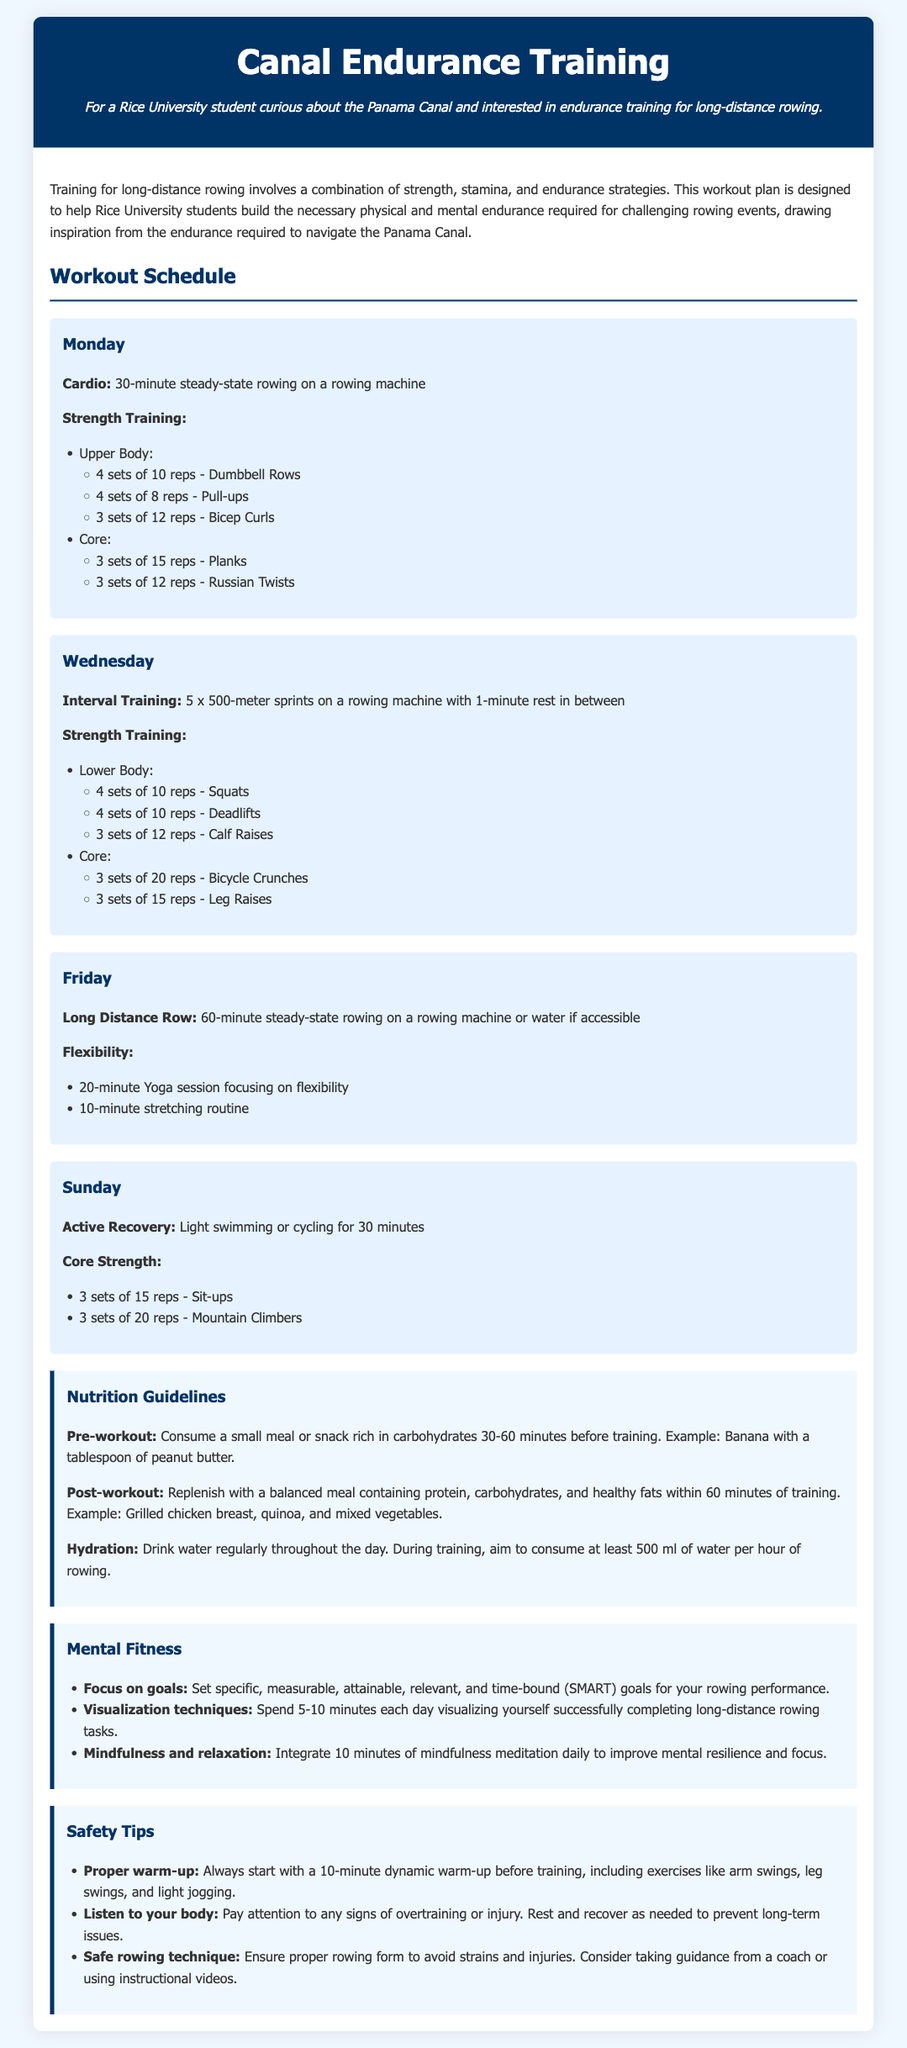What is the title of the document? The title is indicated at the top of the document.
Answer: Canal Endurance Training: Building Strength and Stamina for Long-Distance Rowing How many sets of Bicep Curls are recommended on Monday? The number of sets for Bicep Curls is listed under the Monday workout section.
Answer: 3 sets of 12 reps What type of training is scheduled for Wednesday? The type of training is specified in the workout schedule for that day.
Answer: Interval Training What is suggested for flexibility on Friday? The flexibility activities are listed under Friday's workout.
Answer: 20-minute Yoga session focusing on flexibility How many minutes of active recovery are recommended on Sunday? This information can be found within the Sunday workout section.
Answer: 30 minutes What should be consumed pre-workout? The document provides nutrition guidelines for pre-workout consumption.
Answer: A small meal or snack rich in carbohydrates How many minutes of mindfulness meditation are suggested daily? The suggestion for mindfulness meditation is mentioned in the mental fitness section.
Answer: 10 minutes What is the maximum duration for the Long Distance Row on Friday? This is specified in the workout schedule for Friday.
Answer: 60-minute 